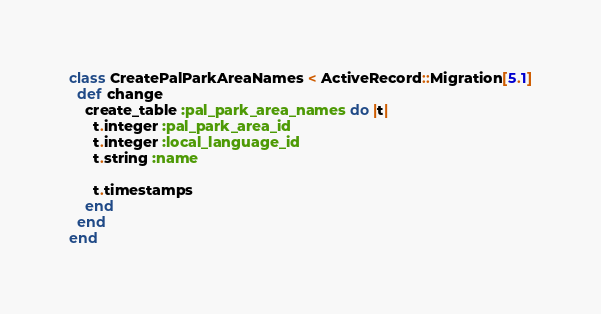Convert code to text. <code><loc_0><loc_0><loc_500><loc_500><_Ruby_>class CreatePalParkAreaNames < ActiveRecord::Migration[5.1]
  def change
    create_table :pal_park_area_names do |t|
      t.integer :pal_park_area_id
      t.integer :local_language_id
      t.string :name

      t.timestamps
    end
  end
end
</code> 